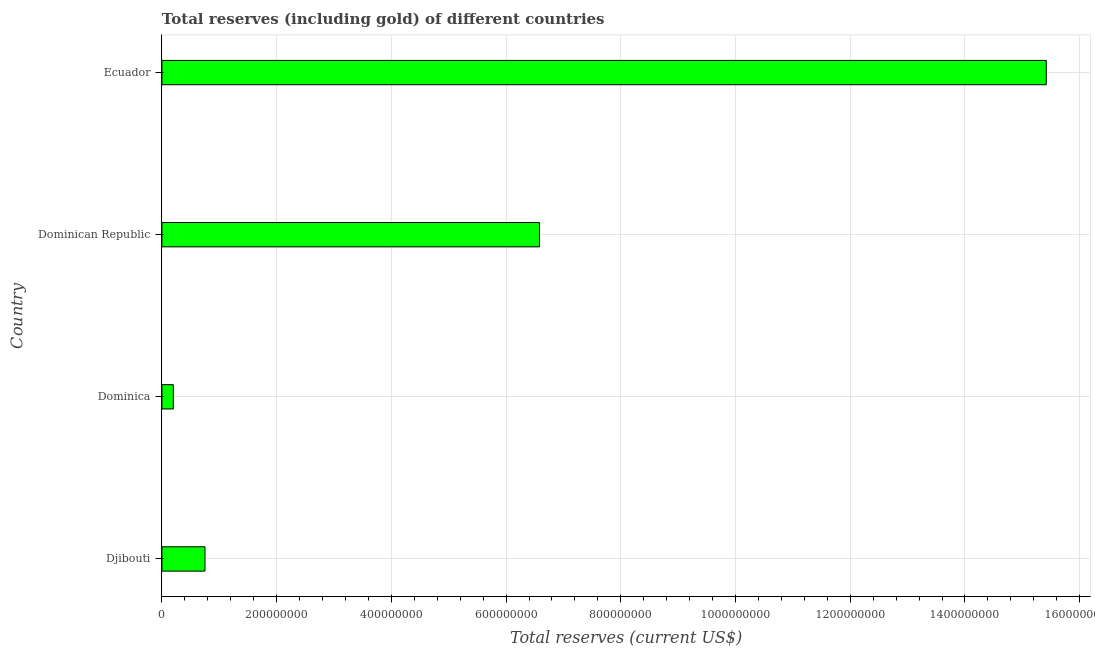What is the title of the graph?
Keep it short and to the point. Total reserves (including gold) of different countries. What is the label or title of the X-axis?
Provide a succinct answer. Total reserves (current US$). What is the label or title of the Y-axis?
Your answer should be compact. Country. What is the total reserves (including gold) in Dominica?
Offer a terse response. 1.99e+07. Across all countries, what is the maximum total reserves (including gold)?
Your answer should be very brief. 1.54e+09. Across all countries, what is the minimum total reserves (including gold)?
Ensure brevity in your answer.  1.99e+07. In which country was the total reserves (including gold) maximum?
Offer a very short reply. Ecuador. In which country was the total reserves (including gold) minimum?
Provide a succinct answer. Dominica. What is the sum of the total reserves (including gold)?
Keep it short and to the point. 2.29e+09. What is the difference between the total reserves (including gold) in Djibouti and Ecuador?
Provide a short and direct response. -1.47e+09. What is the average total reserves (including gold) per country?
Ensure brevity in your answer.  5.74e+08. What is the median total reserves (including gold)?
Offer a very short reply. 3.67e+08. What is the ratio of the total reserves (including gold) in Dominica to that in Ecuador?
Offer a terse response. 0.01. Is the difference between the total reserves (including gold) in Djibouti and Ecuador greater than the difference between any two countries?
Make the answer very short. No. What is the difference between the highest and the second highest total reserves (including gold)?
Make the answer very short. 8.83e+08. Is the sum of the total reserves (including gold) in Djibouti and Ecuador greater than the maximum total reserves (including gold) across all countries?
Make the answer very short. Yes. What is the difference between the highest and the lowest total reserves (including gold)?
Ensure brevity in your answer.  1.52e+09. In how many countries, is the total reserves (including gold) greater than the average total reserves (including gold) taken over all countries?
Give a very brief answer. 2. How many bars are there?
Ensure brevity in your answer.  4. Are all the bars in the graph horizontal?
Your answer should be compact. Yes. What is the Total reserves (current US$) of Djibouti?
Ensure brevity in your answer.  7.51e+07. What is the Total reserves (current US$) of Dominica?
Offer a terse response. 1.99e+07. What is the Total reserves (current US$) of Dominican Republic?
Ensure brevity in your answer.  6.58e+08. What is the Total reserves (current US$) of Ecuador?
Provide a succinct answer. 1.54e+09. What is the difference between the Total reserves (current US$) in Djibouti and Dominica?
Ensure brevity in your answer.  5.52e+07. What is the difference between the Total reserves (current US$) in Djibouti and Dominican Republic?
Keep it short and to the point. -5.83e+08. What is the difference between the Total reserves (current US$) in Djibouti and Ecuador?
Your answer should be compact. -1.47e+09. What is the difference between the Total reserves (current US$) in Dominica and Dominican Republic?
Offer a very short reply. -6.38e+08. What is the difference between the Total reserves (current US$) in Dominica and Ecuador?
Keep it short and to the point. -1.52e+09. What is the difference between the Total reserves (current US$) in Dominican Republic and Ecuador?
Provide a succinct answer. -8.83e+08. What is the ratio of the Total reserves (current US$) in Djibouti to that in Dominica?
Offer a very short reply. 3.77. What is the ratio of the Total reserves (current US$) in Djibouti to that in Dominican Republic?
Your response must be concise. 0.11. What is the ratio of the Total reserves (current US$) in Djibouti to that in Ecuador?
Make the answer very short. 0.05. What is the ratio of the Total reserves (current US$) in Dominica to that in Dominican Republic?
Give a very brief answer. 0.03. What is the ratio of the Total reserves (current US$) in Dominica to that in Ecuador?
Provide a succinct answer. 0.01. What is the ratio of the Total reserves (current US$) in Dominican Republic to that in Ecuador?
Make the answer very short. 0.43. 